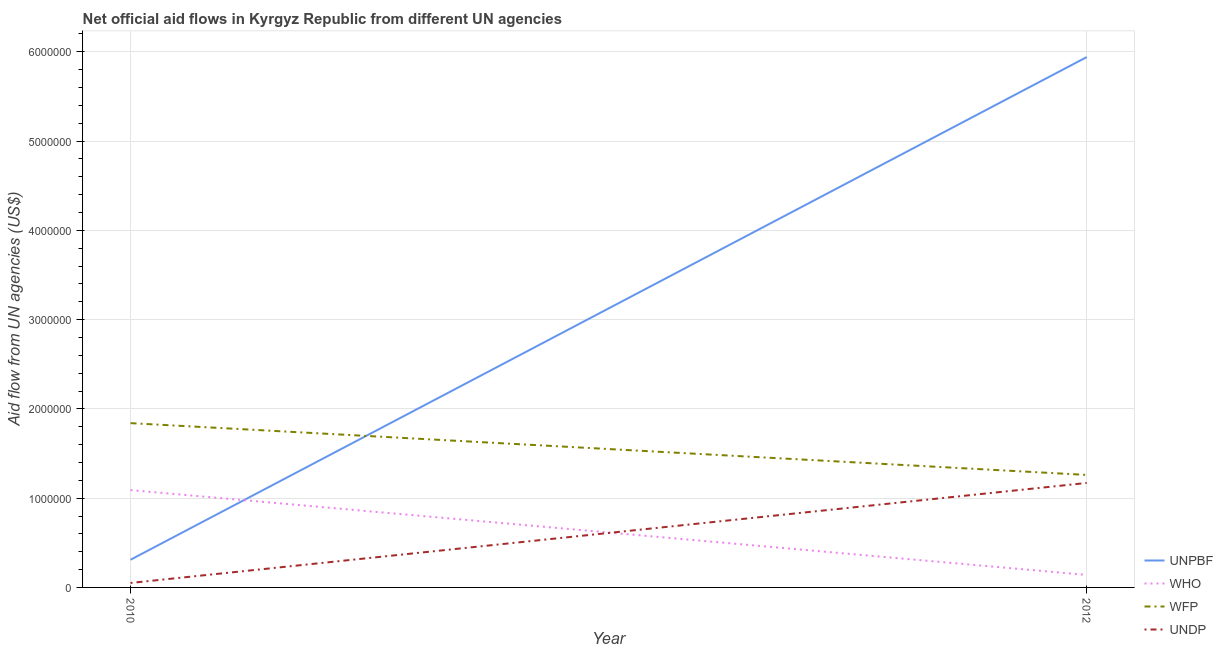Is the number of lines equal to the number of legend labels?
Your response must be concise. Yes. What is the amount of aid given by unpbf in 2010?
Your answer should be very brief. 3.10e+05. Across all years, what is the maximum amount of aid given by wfp?
Keep it short and to the point. 1.84e+06. Across all years, what is the minimum amount of aid given by undp?
Your answer should be compact. 5.00e+04. In which year was the amount of aid given by who minimum?
Your answer should be very brief. 2012. What is the total amount of aid given by who in the graph?
Your response must be concise. 1.23e+06. What is the difference between the amount of aid given by unpbf in 2010 and that in 2012?
Give a very brief answer. -5.63e+06. What is the difference between the amount of aid given by unpbf in 2012 and the amount of aid given by wfp in 2010?
Your answer should be very brief. 4.10e+06. What is the average amount of aid given by who per year?
Offer a terse response. 6.15e+05. In the year 2010, what is the difference between the amount of aid given by wfp and amount of aid given by who?
Ensure brevity in your answer.  7.50e+05. In how many years, is the amount of aid given by undp greater than 5800000 US$?
Make the answer very short. 0. What is the ratio of the amount of aid given by undp in 2010 to that in 2012?
Provide a short and direct response. 0.04. Is the amount of aid given by wfp in 2010 less than that in 2012?
Your answer should be compact. No. Is it the case that in every year, the sum of the amount of aid given by unpbf and amount of aid given by wfp is greater than the sum of amount of aid given by who and amount of aid given by undp?
Your answer should be compact. No. Does the amount of aid given by unpbf monotonically increase over the years?
Your response must be concise. Yes. How many lines are there?
Make the answer very short. 4. How many years are there in the graph?
Offer a terse response. 2. What is the difference between two consecutive major ticks on the Y-axis?
Provide a succinct answer. 1.00e+06. Does the graph contain any zero values?
Your answer should be compact. No. Does the graph contain grids?
Make the answer very short. Yes. How many legend labels are there?
Keep it short and to the point. 4. What is the title of the graph?
Make the answer very short. Net official aid flows in Kyrgyz Republic from different UN agencies. Does "Taxes on income" appear as one of the legend labels in the graph?
Make the answer very short. No. What is the label or title of the Y-axis?
Offer a terse response. Aid flow from UN agencies (US$). What is the Aid flow from UN agencies (US$) of UNPBF in 2010?
Your response must be concise. 3.10e+05. What is the Aid flow from UN agencies (US$) in WHO in 2010?
Keep it short and to the point. 1.09e+06. What is the Aid flow from UN agencies (US$) of WFP in 2010?
Provide a short and direct response. 1.84e+06. What is the Aid flow from UN agencies (US$) of UNPBF in 2012?
Your response must be concise. 5.94e+06. What is the Aid flow from UN agencies (US$) of WHO in 2012?
Provide a short and direct response. 1.40e+05. What is the Aid flow from UN agencies (US$) of WFP in 2012?
Offer a terse response. 1.26e+06. What is the Aid flow from UN agencies (US$) in UNDP in 2012?
Your answer should be compact. 1.17e+06. Across all years, what is the maximum Aid flow from UN agencies (US$) in UNPBF?
Give a very brief answer. 5.94e+06. Across all years, what is the maximum Aid flow from UN agencies (US$) in WHO?
Offer a very short reply. 1.09e+06. Across all years, what is the maximum Aid flow from UN agencies (US$) in WFP?
Your answer should be compact. 1.84e+06. Across all years, what is the maximum Aid flow from UN agencies (US$) in UNDP?
Your response must be concise. 1.17e+06. Across all years, what is the minimum Aid flow from UN agencies (US$) of UNPBF?
Your answer should be very brief. 3.10e+05. Across all years, what is the minimum Aid flow from UN agencies (US$) of WHO?
Your answer should be compact. 1.40e+05. Across all years, what is the minimum Aid flow from UN agencies (US$) in WFP?
Give a very brief answer. 1.26e+06. Across all years, what is the minimum Aid flow from UN agencies (US$) of UNDP?
Ensure brevity in your answer.  5.00e+04. What is the total Aid flow from UN agencies (US$) of UNPBF in the graph?
Provide a succinct answer. 6.25e+06. What is the total Aid flow from UN agencies (US$) of WHO in the graph?
Your answer should be very brief. 1.23e+06. What is the total Aid flow from UN agencies (US$) in WFP in the graph?
Ensure brevity in your answer.  3.10e+06. What is the total Aid flow from UN agencies (US$) in UNDP in the graph?
Make the answer very short. 1.22e+06. What is the difference between the Aid flow from UN agencies (US$) of UNPBF in 2010 and that in 2012?
Your answer should be very brief. -5.63e+06. What is the difference between the Aid flow from UN agencies (US$) in WHO in 2010 and that in 2012?
Provide a succinct answer. 9.50e+05. What is the difference between the Aid flow from UN agencies (US$) in WFP in 2010 and that in 2012?
Your answer should be very brief. 5.80e+05. What is the difference between the Aid flow from UN agencies (US$) in UNDP in 2010 and that in 2012?
Your response must be concise. -1.12e+06. What is the difference between the Aid flow from UN agencies (US$) in UNPBF in 2010 and the Aid flow from UN agencies (US$) in WHO in 2012?
Offer a very short reply. 1.70e+05. What is the difference between the Aid flow from UN agencies (US$) in UNPBF in 2010 and the Aid flow from UN agencies (US$) in WFP in 2012?
Keep it short and to the point. -9.50e+05. What is the difference between the Aid flow from UN agencies (US$) in UNPBF in 2010 and the Aid flow from UN agencies (US$) in UNDP in 2012?
Keep it short and to the point. -8.60e+05. What is the difference between the Aid flow from UN agencies (US$) of WHO in 2010 and the Aid flow from UN agencies (US$) of WFP in 2012?
Your answer should be very brief. -1.70e+05. What is the difference between the Aid flow from UN agencies (US$) in WHO in 2010 and the Aid flow from UN agencies (US$) in UNDP in 2012?
Make the answer very short. -8.00e+04. What is the difference between the Aid flow from UN agencies (US$) of WFP in 2010 and the Aid flow from UN agencies (US$) of UNDP in 2012?
Give a very brief answer. 6.70e+05. What is the average Aid flow from UN agencies (US$) in UNPBF per year?
Provide a succinct answer. 3.12e+06. What is the average Aid flow from UN agencies (US$) of WHO per year?
Your response must be concise. 6.15e+05. What is the average Aid flow from UN agencies (US$) of WFP per year?
Provide a succinct answer. 1.55e+06. What is the average Aid flow from UN agencies (US$) in UNDP per year?
Offer a very short reply. 6.10e+05. In the year 2010, what is the difference between the Aid flow from UN agencies (US$) in UNPBF and Aid flow from UN agencies (US$) in WHO?
Give a very brief answer. -7.80e+05. In the year 2010, what is the difference between the Aid flow from UN agencies (US$) in UNPBF and Aid flow from UN agencies (US$) in WFP?
Provide a short and direct response. -1.53e+06. In the year 2010, what is the difference between the Aid flow from UN agencies (US$) of WHO and Aid flow from UN agencies (US$) of WFP?
Ensure brevity in your answer.  -7.50e+05. In the year 2010, what is the difference between the Aid flow from UN agencies (US$) in WHO and Aid flow from UN agencies (US$) in UNDP?
Provide a succinct answer. 1.04e+06. In the year 2010, what is the difference between the Aid flow from UN agencies (US$) of WFP and Aid flow from UN agencies (US$) of UNDP?
Offer a terse response. 1.79e+06. In the year 2012, what is the difference between the Aid flow from UN agencies (US$) of UNPBF and Aid flow from UN agencies (US$) of WHO?
Offer a terse response. 5.80e+06. In the year 2012, what is the difference between the Aid flow from UN agencies (US$) in UNPBF and Aid flow from UN agencies (US$) in WFP?
Provide a short and direct response. 4.68e+06. In the year 2012, what is the difference between the Aid flow from UN agencies (US$) of UNPBF and Aid flow from UN agencies (US$) of UNDP?
Make the answer very short. 4.77e+06. In the year 2012, what is the difference between the Aid flow from UN agencies (US$) of WHO and Aid flow from UN agencies (US$) of WFP?
Keep it short and to the point. -1.12e+06. In the year 2012, what is the difference between the Aid flow from UN agencies (US$) in WHO and Aid flow from UN agencies (US$) in UNDP?
Provide a short and direct response. -1.03e+06. In the year 2012, what is the difference between the Aid flow from UN agencies (US$) of WFP and Aid flow from UN agencies (US$) of UNDP?
Offer a terse response. 9.00e+04. What is the ratio of the Aid flow from UN agencies (US$) in UNPBF in 2010 to that in 2012?
Offer a terse response. 0.05. What is the ratio of the Aid flow from UN agencies (US$) in WHO in 2010 to that in 2012?
Provide a succinct answer. 7.79. What is the ratio of the Aid flow from UN agencies (US$) of WFP in 2010 to that in 2012?
Keep it short and to the point. 1.46. What is the ratio of the Aid flow from UN agencies (US$) in UNDP in 2010 to that in 2012?
Offer a very short reply. 0.04. What is the difference between the highest and the second highest Aid flow from UN agencies (US$) in UNPBF?
Your response must be concise. 5.63e+06. What is the difference between the highest and the second highest Aid flow from UN agencies (US$) in WHO?
Your response must be concise. 9.50e+05. What is the difference between the highest and the second highest Aid flow from UN agencies (US$) in WFP?
Keep it short and to the point. 5.80e+05. What is the difference between the highest and the second highest Aid flow from UN agencies (US$) of UNDP?
Make the answer very short. 1.12e+06. What is the difference between the highest and the lowest Aid flow from UN agencies (US$) of UNPBF?
Give a very brief answer. 5.63e+06. What is the difference between the highest and the lowest Aid flow from UN agencies (US$) of WHO?
Offer a very short reply. 9.50e+05. What is the difference between the highest and the lowest Aid flow from UN agencies (US$) in WFP?
Keep it short and to the point. 5.80e+05. What is the difference between the highest and the lowest Aid flow from UN agencies (US$) of UNDP?
Provide a short and direct response. 1.12e+06. 